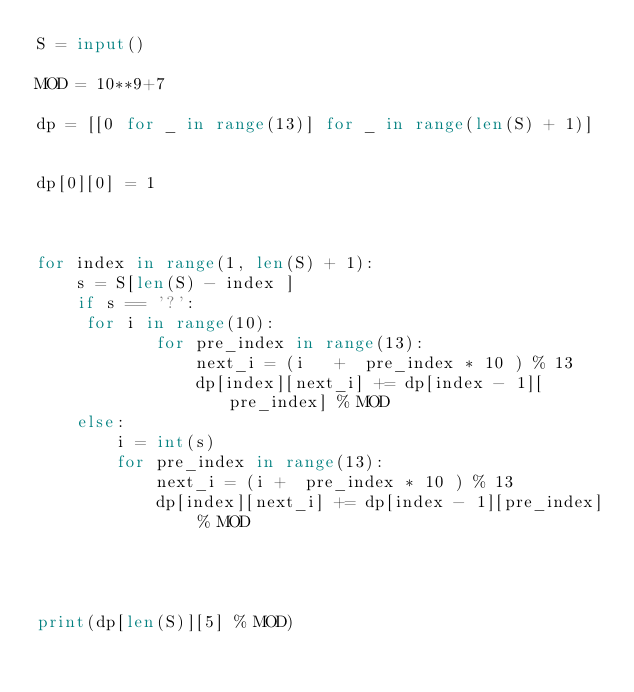<code> <loc_0><loc_0><loc_500><loc_500><_Python_>S = input()

MOD = 10**9+7

dp = [[0 for _ in range(13)] for _ in range(len(S) + 1)]


dp[0][0] = 1



for index in range(1, len(S) + 1):
    s = S[len(S) - index ]
    if s == '?':
   	 for i in range(10):
            for pre_index in range(13):
                next_i = (i   +  pre_index * 10 ) % 13
                dp[index][next_i] += dp[index - 1][pre_index] % MOD
    else:
        i = int(s)
        for pre_index in range(13):
            next_i = (i +  pre_index * 10 ) % 13
            dp[index][next_i] += dp[index - 1][pre_index] % MOD




print(dp[len(S)][5] % MOD)

</code> 